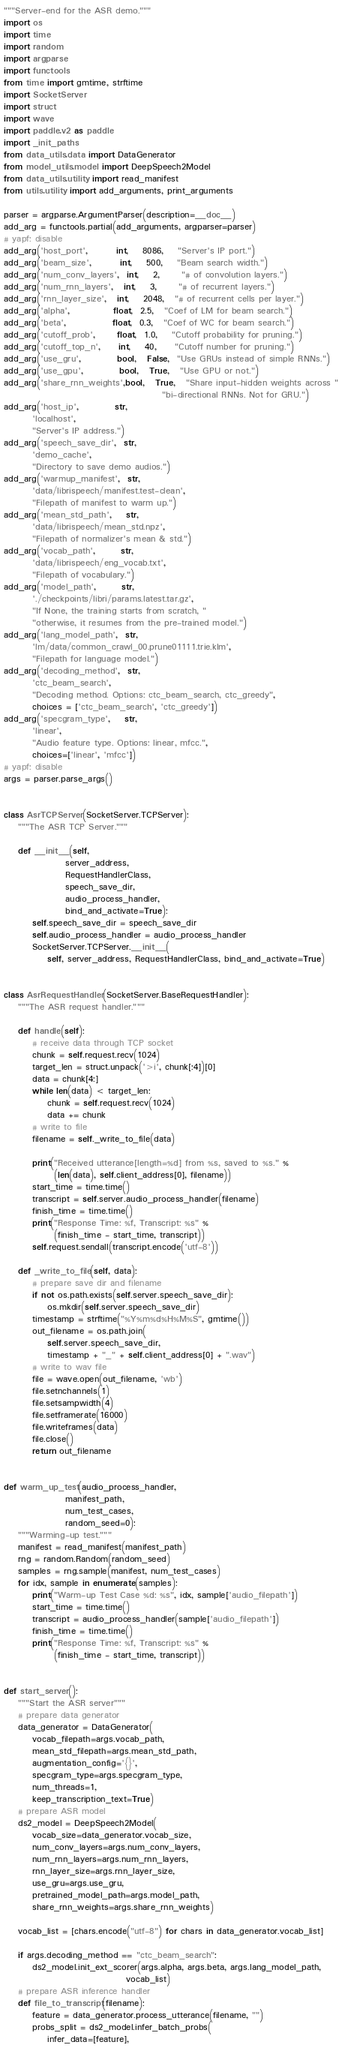<code> <loc_0><loc_0><loc_500><loc_500><_Python_>"""Server-end for the ASR demo."""
import os
import time
import random
import argparse
import functools
from time import gmtime, strftime
import SocketServer
import struct
import wave
import paddle.v2 as paddle
import _init_paths
from data_utils.data import DataGenerator
from model_utils.model import DeepSpeech2Model
from data_utils.utility import read_manifest
from utils.utility import add_arguments, print_arguments

parser = argparse.ArgumentParser(description=__doc__)
add_arg = functools.partial(add_arguments, argparser=parser)
# yapf: disable
add_arg('host_port',        int,    8086,    "Server's IP port.")
add_arg('beam_size',        int,    500,    "Beam search width.")
add_arg('num_conv_layers',  int,    2,      "# of convolution layers.")
add_arg('num_rnn_layers',   int,    3,      "# of recurrent layers.")
add_arg('rnn_layer_size',   int,    2048,   "# of recurrent cells per layer.")
add_arg('alpha',            float,  2.5,   "Coef of LM for beam search.")
add_arg('beta',             float,  0.3,   "Coef of WC for beam search.")
add_arg('cutoff_prob',      float,  1.0,    "Cutoff probability for pruning.")
add_arg('cutoff_top_n',     int,    40,     "Cutoff number for pruning.")
add_arg('use_gru',          bool,   False,  "Use GRUs instead of simple RNNs.")
add_arg('use_gpu',          bool,   True,   "Use GPU or not.")
add_arg('share_rnn_weights',bool,   True,   "Share input-hidden weights across "
                                            "bi-directional RNNs. Not for GRU.")
add_arg('host_ip',          str,
        'localhost',
        "Server's IP address.")
add_arg('speech_save_dir',  str,
        'demo_cache',
        "Directory to save demo audios.")
add_arg('warmup_manifest',  str,
        'data/librispeech/manifest.test-clean',
        "Filepath of manifest to warm up.")
add_arg('mean_std_path',    str,
        'data/librispeech/mean_std.npz',
        "Filepath of normalizer's mean & std.")
add_arg('vocab_path',       str,
        'data/librispeech/eng_vocab.txt',
        "Filepath of vocabulary.")
add_arg('model_path',       str,
        './checkpoints/libri/params.latest.tar.gz',
        "If None, the training starts from scratch, "
        "otherwise, it resumes from the pre-trained model.")
add_arg('lang_model_path',  str,
        'lm/data/common_crawl_00.prune01111.trie.klm',
        "Filepath for language model.")
add_arg('decoding_method',  str,
        'ctc_beam_search',
        "Decoding method. Options: ctc_beam_search, ctc_greedy",
        choices = ['ctc_beam_search', 'ctc_greedy'])
add_arg('specgram_type',    str,
        'linear',
        "Audio feature type. Options: linear, mfcc.",
        choices=['linear', 'mfcc'])
# yapf: disable
args = parser.parse_args()


class AsrTCPServer(SocketServer.TCPServer):
    """The ASR TCP Server."""

    def __init__(self,
                 server_address,
                 RequestHandlerClass,
                 speech_save_dir,
                 audio_process_handler,
                 bind_and_activate=True):
        self.speech_save_dir = speech_save_dir
        self.audio_process_handler = audio_process_handler
        SocketServer.TCPServer.__init__(
            self, server_address, RequestHandlerClass, bind_and_activate=True)


class AsrRequestHandler(SocketServer.BaseRequestHandler):
    """The ASR request handler."""

    def handle(self):
        # receive data through TCP socket
        chunk = self.request.recv(1024)
        target_len = struct.unpack('>i', chunk[:4])[0]
        data = chunk[4:]
        while len(data) < target_len:
            chunk = self.request.recv(1024)
            data += chunk
        # write to file
        filename = self._write_to_file(data)

        print("Received utterance[length=%d] from %s, saved to %s." %
              (len(data), self.client_address[0], filename))
        start_time = time.time()
        transcript = self.server.audio_process_handler(filename)
        finish_time = time.time()
        print("Response Time: %f, Transcript: %s" %
              (finish_time - start_time, transcript))
        self.request.sendall(transcript.encode('utf-8'))

    def _write_to_file(self, data):
        # prepare save dir and filename
        if not os.path.exists(self.server.speech_save_dir):
            os.mkdir(self.server.speech_save_dir)
        timestamp = strftime("%Y%m%d%H%M%S", gmtime())
        out_filename = os.path.join(
            self.server.speech_save_dir,
            timestamp + "_" + self.client_address[0] + ".wav")
        # write to wav file
        file = wave.open(out_filename, 'wb')
        file.setnchannels(1)
        file.setsampwidth(4)
        file.setframerate(16000)
        file.writeframes(data)
        file.close()
        return out_filename


def warm_up_test(audio_process_handler,
                 manifest_path,
                 num_test_cases,
                 random_seed=0):
    """Warming-up test."""
    manifest = read_manifest(manifest_path)
    rng = random.Random(random_seed)
    samples = rng.sample(manifest, num_test_cases)
    for idx, sample in enumerate(samples):
        print("Warm-up Test Case %d: %s", idx, sample['audio_filepath'])
        start_time = time.time()
        transcript = audio_process_handler(sample['audio_filepath'])
        finish_time = time.time()
        print("Response Time: %f, Transcript: %s" %
              (finish_time - start_time, transcript))


def start_server():
    """Start the ASR server"""
    # prepare data generator
    data_generator = DataGenerator(
        vocab_filepath=args.vocab_path,
        mean_std_filepath=args.mean_std_path,
        augmentation_config='{}',
        specgram_type=args.specgram_type,
        num_threads=1,
        keep_transcription_text=True)
    # prepare ASR model
    ds2_model = DeepSpeech2Model(
        vocab_size=data_generator.vocab_size,
        num_conv_layers=args.num_conv_layers,
        num_rnn_layers=args.num_rnn_layers,
        rnn_layer_size=args.rnn_layer_size,
        use_gru=args.use_gru,
        pretrained_model_path=args.model_path,
        share_rnn_weights=args.share_rnn_weights)

    vocab_list = [chars.encode("utf-8") for chars in data_generator.vocab_list]

    if args.decoding_method == "ctc_beam_search":
        ds2_model.init_ext_scorer(args.alpha, args.beta, args.lang_model_path,
                                  vocab_list)
    # prepare ASR inference handler
    def file_to_transcript(filename):
        feature = data_generator.process_utterance(filename, "")
        probs_split = ds2_model.infer_batch_probs(
            infer_data=[feature],</code> 